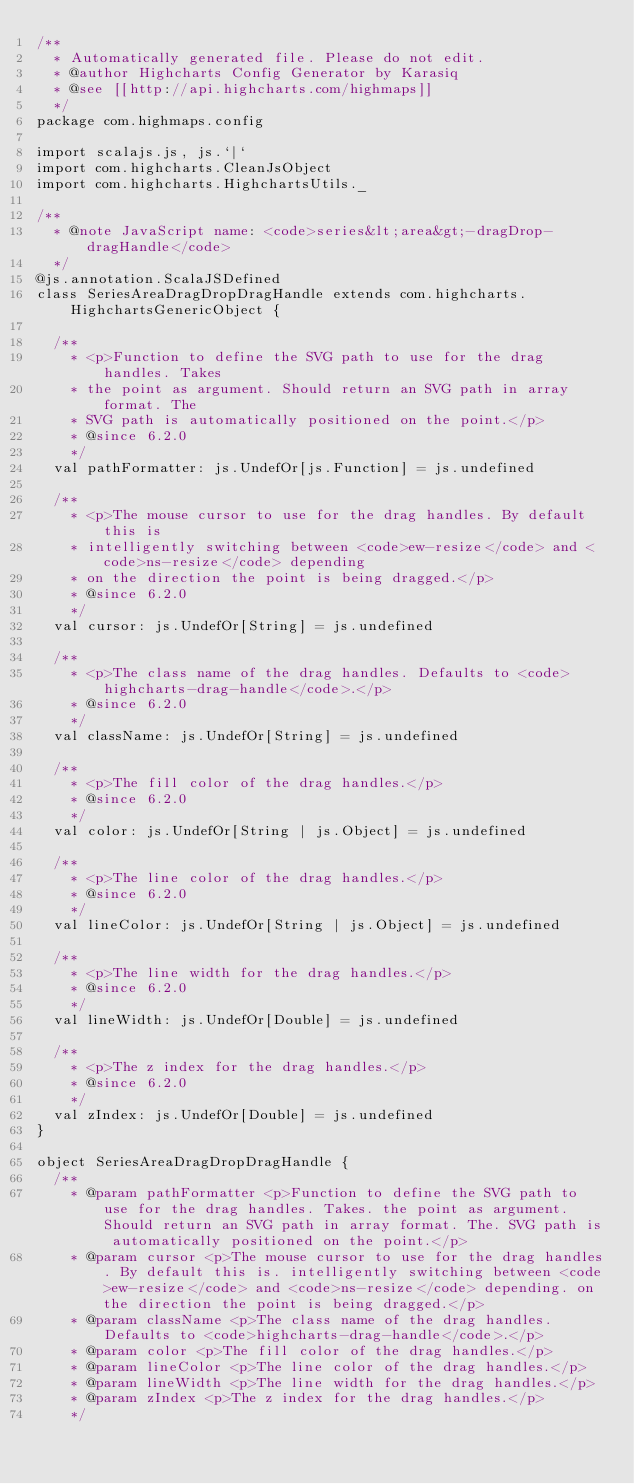<code> <loc_0><loc_0><loc_500><loc_500><_Scala_>/**
  * Automatically generated file. Please do not edit.
  * @author Highcharts Config Generator by Karasiq
  * @see [[http://api.highcharts.com/highmaps]]
  */
package com.highmaps.config

import scalajs.js, js.`|`
import com.highcharts.CleanJsObject
import com.highcharts.HighchartsUtils._

/**
  * @note JavaScript name: <code>series&lt;area&gt;-dragDrop-dragHandle</code>
  */
@js.annotation.ScalaJSDefined
class SeriesAreaDragDropDragHandle extends com.highcharts.HighchartsGenericObject {

  /**
    * <p>Function to define the SVG path to use for the drag handles. Takes
    * the point as argument. Should return an SVG path in array format. The
    * SVG path is automatically positioned on the point.</p>
    * @since 6.2.0
    */
  val pathFormatter: js.UndefOr[js.Function] = js.undefined

  /**
    * <p>The mouse cursor to use for the drag handles. By default this is
    * intelligently switching between <code>ew-resize</code> and <code>ns-resize</code> depending
    * on the direction the point is being dragged.</p>
    * @since 6.2.0
    */
  val cursor: js.UndefOr[String] = js.undefined

  /**
    * <p>The class name of the drag handles. Defaults to <code>highcharts-drag-handle</code>.</p>
    * @since 6.2.0
    */
  val className: js.UndefOr[String] = js.undefined

  /**
    * <p>The fill color of the drag handles.</p>
    * @since 6.2.0
    */
  val color: js.UndefOr[String | js.Object] = js.undefined

  /**
    * <p>The line color of the drag handles.</p>
    * @since 6.2.0
    */
  val lineColor: js.UndefOr[String | js.Object] = js.undefined

  /**
    * <p>The line width for the drag handles.</p>
    * @since 6.2.0
    */
  val lineWidth: js.UndefOr[Double] = js.undefined

  /**
    * <p>The z index for the drag handles.</p>
    * @since 6.2.0
    */
  val zIndex: js.UndefOr[Double] = js.undefined
}

object SeriesAreaDragDropDragHandle {
  /**
    * @param pathFormatter <p>Function to define the SVG path to use for the drag handles. Takes. the point as argument. Should return an SVG path in array format. The. SVG path is automatically positioned on the point.</p>
    * @param cursor <p>The mouse cursor to use for the drag handles. By default this is. intelligently switching between <code>ew-resize</code> and <code>ns-resize</code> depending. on the direction the point is being dragged.</p>
    * @param className <p>The class name of the drag handles. Defaults to <code>highcharts-drag-handle</code>.</p>
    * @param color <p>The fill color of the drag handles.</p>
    * @param lineColor <p>The line color of the drag handles.</p>
    * @param lineWidth <p>The line width for the drag handles.</p>
    * @param zIndex <p>The z index for the drag handles.</p>
    */</code> 